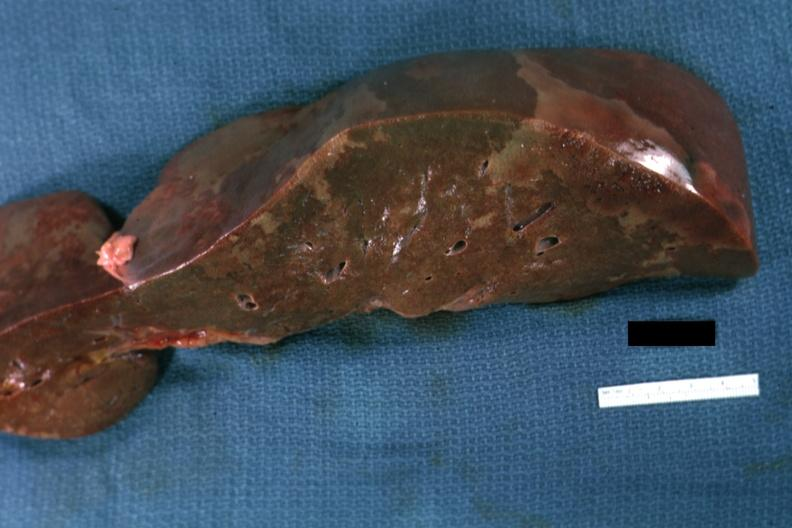s anomalous origin present?
Answer the question using a single word or phrase. No 